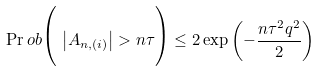Convert formula to latex. <formula><loc_0><loc_0><loc_500><loc_500>\Pr o b \Big { ( } \, \left | A _ { n , ( i ) } \right | > n \tau \Big { ) } \leq 2 \exp \left ( - \frac { n \tau ^ { 2 } q ^ { 2 } } { 2 } \right )</formula> 